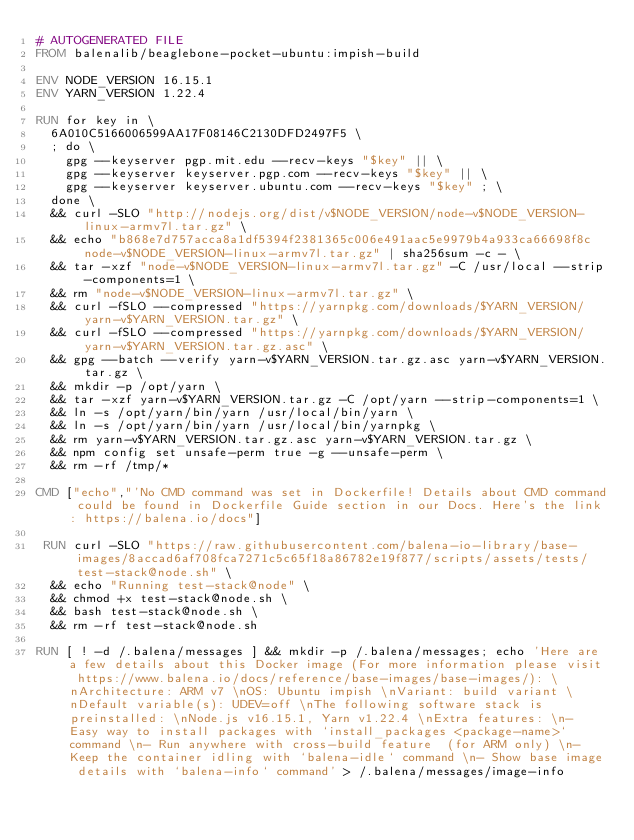<code> <loc_0><loc_0><loc_500><loc_500><_Dockerfile_># AUTOGENERATED FILE
FROM balenalib/beaglebone-pocket-ubuntu:impish-build

ENV NODE_VERSION 16.15.1
ENV YARN_VERSION 1.22.4

RUN for key in \
	6A010C5166006599AA17F08146C2130DFD2497F5 \
	; do \
		gpg --keyserver pgp.mit.edu --recv-keys "$key" || \
		gpg --keyserver keyserver.pgp.com --recv-keys "$key" || \
		gpg --keyserver keyserver.ubuntu.com --recv-keys "$key" ; \
	done \
	&& curl -SLO "http://nodejs.org/dist/v$NODE_VERSION/node-v$NODE_VERSION-linux-armv7l.tar.gz" \
	&& echo "b868e7d757acca8a1df5394f2381365c006e491aac5e9979b4a933ca66698f8c  node-v$NODE_VERSION-linux-armv7l.tar.gz" | sha256sum -c - \
	&& tar -xzf "node-v$NODE_VERSION-linux-armv7l.tar.gz" -C /usr/local --strip-components=1 \
	&& rm "node-v$NODE_VERSION-linux-armv7l.tar.gz" \
	&& curl -fSLO --compressed "https://yarnpkg.com/downloads/$YARN_VERSION/yarn-v$YARN_VERSION.tar.gz" \
	&& curl -fSLO --compressed "https://yarnpkg.com/downloads/$YARN_VERSION/yarn-v$YARN_VERSION.tar.gz.asc" \
	&& gpg --batch --verify yarn-v$YARN_VERSION.tar.gz.asc yarn-v$YARN_VERSION.tar.gz \
	&& mkdir -p /opt/yarn \
	&& tar -xzf yarn-v$YARN_VERSION.tar.gz -C /opt/yarn --strip-components=1 \
	&& ln -s /opt/yarn/bin/yarn /usr/local/bin/yarn \
	&& ln -s /opt/yarn/bin/yarn /usr/local/bin/yarnpkg \
	&& rm yarn-v$YARN_VERSION.tar.gz.asc yarn-v$YARN_VERSION.tar.gz \
	&& npm config set unsafe-perm true -g --unsafe-perm \
	&& rm -rf /tmp/*

CMD ["echo","'No CMD command was set in Dockerfile! Details about CMD command could be found in Dockerfile Guide section in our Docs. Here's the link: https://balena.io/docs"]

 RUN curl -SLO "https://raw.githubusercontent.com/balena-io-library/base-images/8accad6af708fca7271c5c65f18a86782e19f877/scripts/assets/tests/test-stack@node.sh" \
  && echo "Running test-stack@node" \
  && chmod +x test-stack@node.sh \
  && bash test-stack@node.sh \
  && rm -rf test-stack@node.sh 

RUN [ ! -d /.balena/messages ] && mkdir -p /.balena/messages; echo 'Here are a few details about this Docker image (For more information please visit https://www.balena.io/docs/reference/base-images/base-images/): \nArchitecture: ARM v7 \nOS: Ubuntu impish \nVariant: build variant \nDefault variable(s): UDEV=off \nThe following software stack is preinstalled: \nNode.js v16.15.1, Yarn v1.22.4 \nExtra features: \n- Easy way to install packages with `install_packages <package-name>` command \n- Run anywhere with cross-build feature  (for ARM only) \n- Keep the container idling with `balena-idle` command \n- Show base image details with `balena-info` command' > /.balena/messages/image-info</code> 